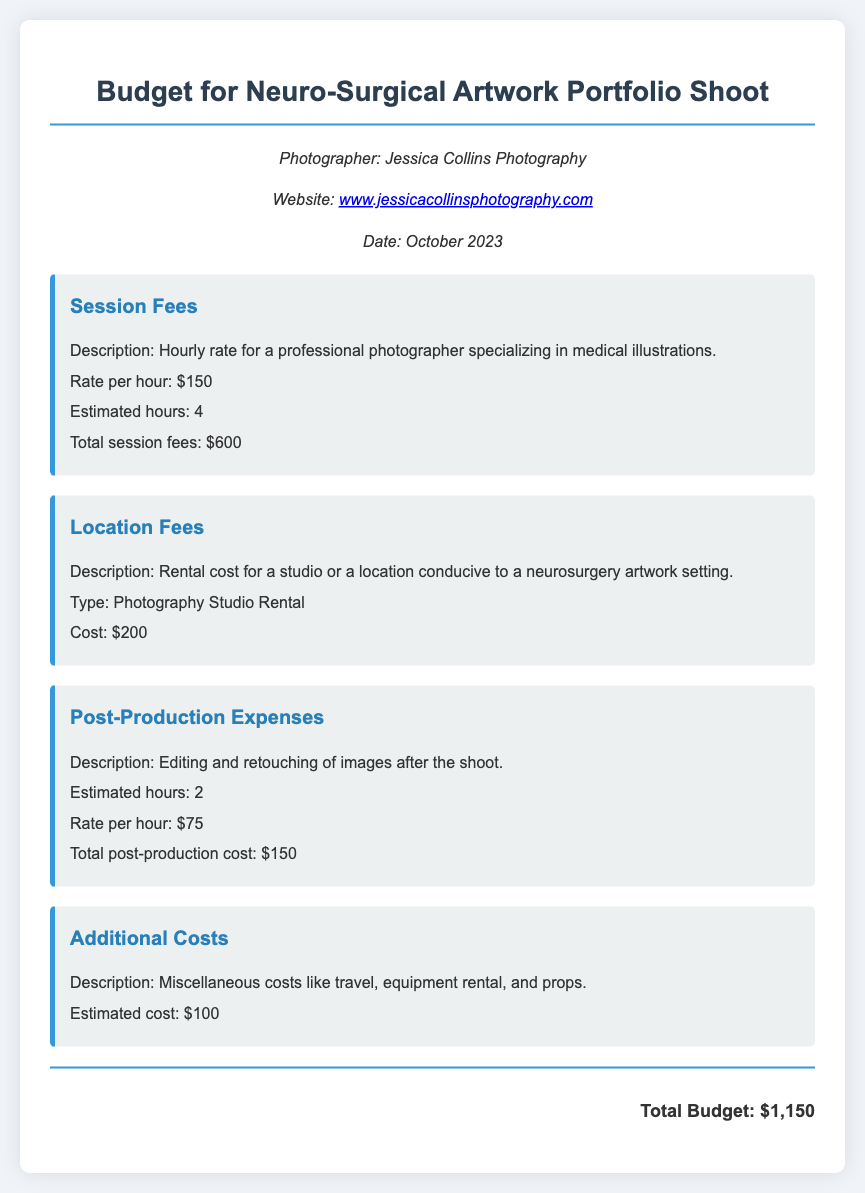what is the photographer's website? The document includes the photographer's website for reference, which is given as a clickable link.
Answer: www.jessicacollinsphotography.com what is the hourly rate for the photographer? The document states the rate per hour for the professional photographer specializing in medical illustrations.
Answer: $150 how many estimated hours are allocated for the session? The document specifies the estimated hours the photographer will be working during the shoot.
Answer: 4 what is the cost for location fees? The document outlines the specific cost associated with renting a studio or photography location.
Answer: $200 what is the total budget for the portfolio shoot? The document concludes with the total budget, which sums all costs mentioned within.
Answer: $1,150 how much will post-production cost? The document details the total cost associated with editing and retouching images after the shoot.
Answer: $150 what are additional costs estimated at? The document notes the estimated miscellaneous costs incurred during the shoot.
Answer: $100 who is the photographer? The document identifies the professional photographer responsible for the portfolio shoot.
Answer: Jessica Collins how many hours are estimated for post-production? The document provides the estimated hours required for post-production editing after the shoot.
Answer: 2 